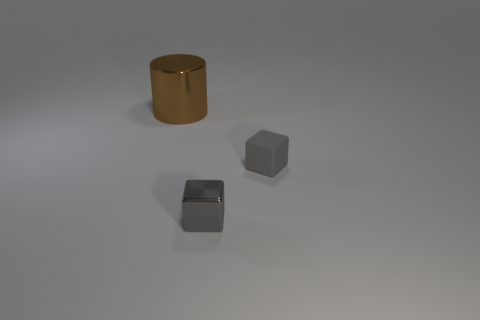What material is the other tiny block that is the same color as the metallic block?
Offer a terse response. Rubber. What is the material of the small block to the left of the gray object that is right of the small metallic thing?
Offer a very short reply. Metal. Are there an equal number of gray metallic blocks to the left of the big brown cylinder and large brown metal cylinders?
Provide a short and direct response. No. What size is the thing that is to the left of the small rubber thing and in front of the large brown shiny thing?
Make the answer very short. Small. The object that is left of the metal object in front of the large metallic thing is what color?
Ensure brevity in your answer.  Brown. How many green objects are large things or metal things?
Keep it short and to the point. 0. There is a thing that is both left of the tiny gray matte object and to the right of the large thing; what is its color?
Offer a terse response. Gray. How many small things are gray metal blocks or blocks?
Provide a succinct answer. 2. The other gray object that is the same shape as the tiny gray matte object is what size?
Keep it short and to the point. Small. There is a tiny matte thing; what shape is it?
Make the answer very short. Cube. 